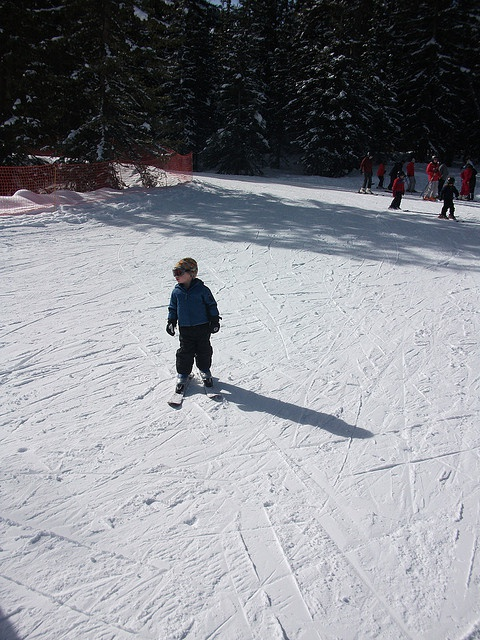Describe the objects in this image and their specific colors. I can see people in black, lightgray, navy, and gray tones, skis in black, gray, and lightgray tones, people in black, gray, lightgray, and darkgray tones, people in black, gray, darkblue, and darkgray tones, and people in black, maroon, and gray tones in this image. 